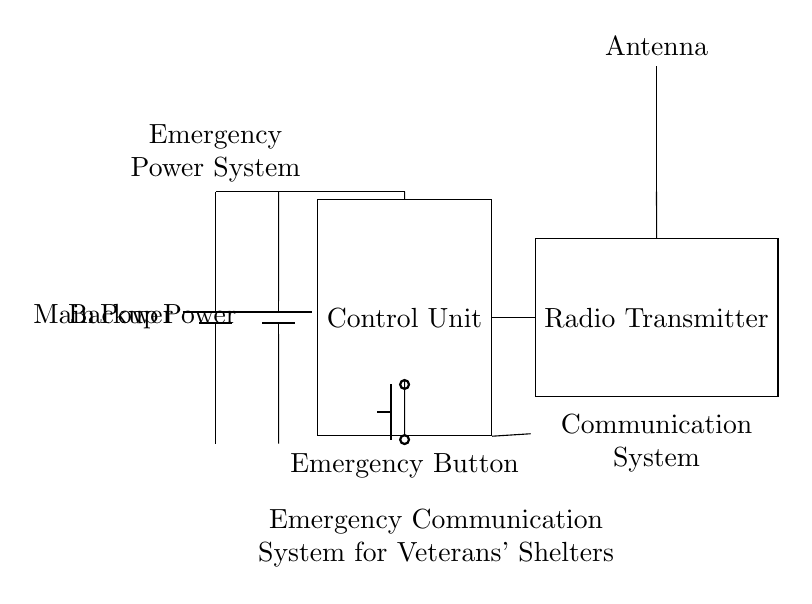What is the main power source in this circuit? The main power source is represented by the battery labeled "Main Power." It's located at the left side of the circuit diagram and connects to the control unit.
Answer: Main Power What component receives input from both power sources? The component that receives input from both the main power and backup power is the control unit. It is positioned in the middle of the circuit and has connections from both batteries.
Answer: Control Unit What component is used to transmit signals? The component used for signal transmission is the radio transmitter, which is labeled as such and is located to the right of the control unit.
Answer: Radio Transmitter What activates the emergency communication system? The emergency communication system is activated by the "Emergency Button," which is located at the bottom of the control unit and connected to it.
Answer: Emergency Button How many power sources are present in the circuit? The circuit has two power sources: the main power and the backup power. Both are represented by batteries on the left side of the circuit diagram.
Answer: Two What is the purpose of the loudspeaker in this circuit? The loudspeaker is used for audio output within the emergency communication system, allowing communication to be audible. It is connected to the control unit, which processes the communication signals.
Answer: Audio output What is the function of the antenna in this circuit? The antenna's function is to receive and transmit radio signals, aiding in the communication aspect of the system. It is positioned at the top right of the diagram and connected to the radio transmitter.
Answer: Radio signals 